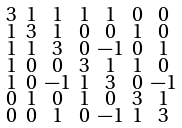<formula> <loc_0><loc_0><loc_500><loc_500>\begin{smallmatrix} 3 & 1 & 1 & 1 & 1 & 0 & 0 \\ 1 & 3 & 1 & 0 & 0 & 1 & 0 \\ 1 & 1 & 3 & 0 & - 1 & 0 & 1 \\ 1 & 0 & 0 & 3 & 1 & 1 & 0 \\ 1 & 0 & - 1 & 1 & 3 & 0 & - 1 \\ 0 & 1 & 0 & 1 & 0 & 3 & 1 \\ 0 & 0 & 1 & 0 & - 1 & 1 & 3 \end{smallmatrix}</formula> 